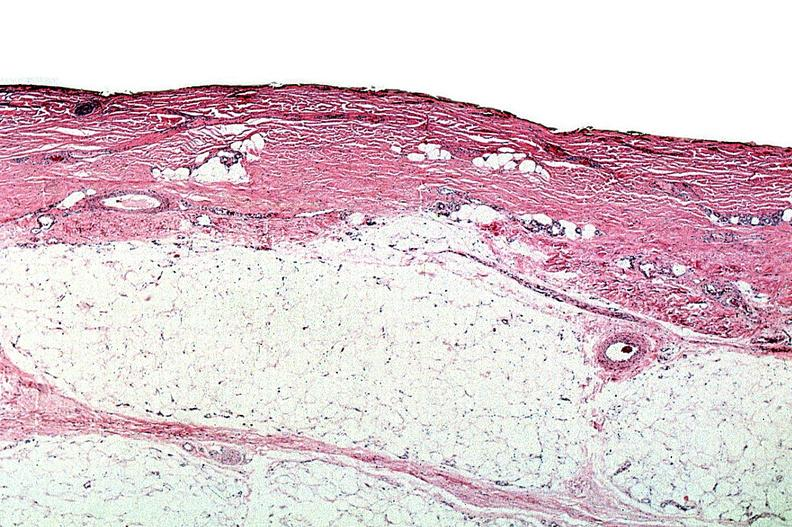does hemisection of nose show thermal burned skin?
Answer the question using a single word or phrase. No 